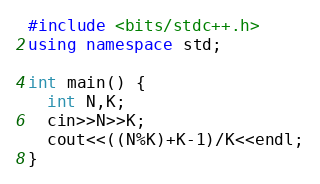<code> <loc_0><loc_0><loc_500><loc_500><_C++_>#include <bits/stdc++.h>
using namespace std;

int main() {
  int N,K;
  cin>>N>>K;
  cout<<((N%K)+K-1)/K<<endl;
}
</code> 